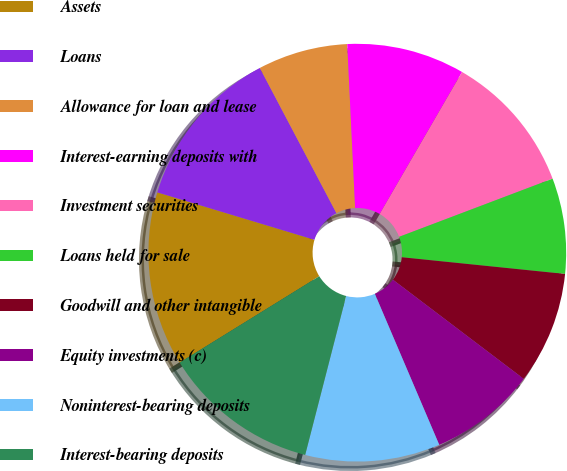<chart> <loc_0><loc_0><loc_500><loc_500><pie_chart><fcel>Assets<fcel>Loans<fcel>Allowance for loan and lease<fcel>Interest-earning deposits with<fcel>Investment securities<fcel>Loans held for sale<fcel>Goodwill and other intangible<fcel>Equity investments (c)<fcel>Noninterest-bearing deposits<fcel>Interest-bearing deposits<nl><fcel>13.48%<fcel>12.61%<fcel>6.96%<fcel>9.13%<fcel>10.87%<fcel>7.39%<fcel>8.7%<fcel>8.26%<fcel>10.43%<fcel>12.17%<nl></chart> 